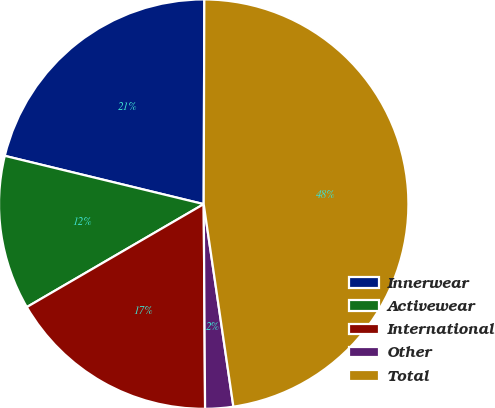<chart> <loc_0><loc_0><loc_500><loc_500><pie_chart><fcel>Innerwear<fcel>Activewear<fcel>International<fcel>Other<fcel>Total<nl><fcel>21.26%<fcel>12.18%<fcel>16.72%<fcel>2.21%<fcel>47.64%<nl></chart> 